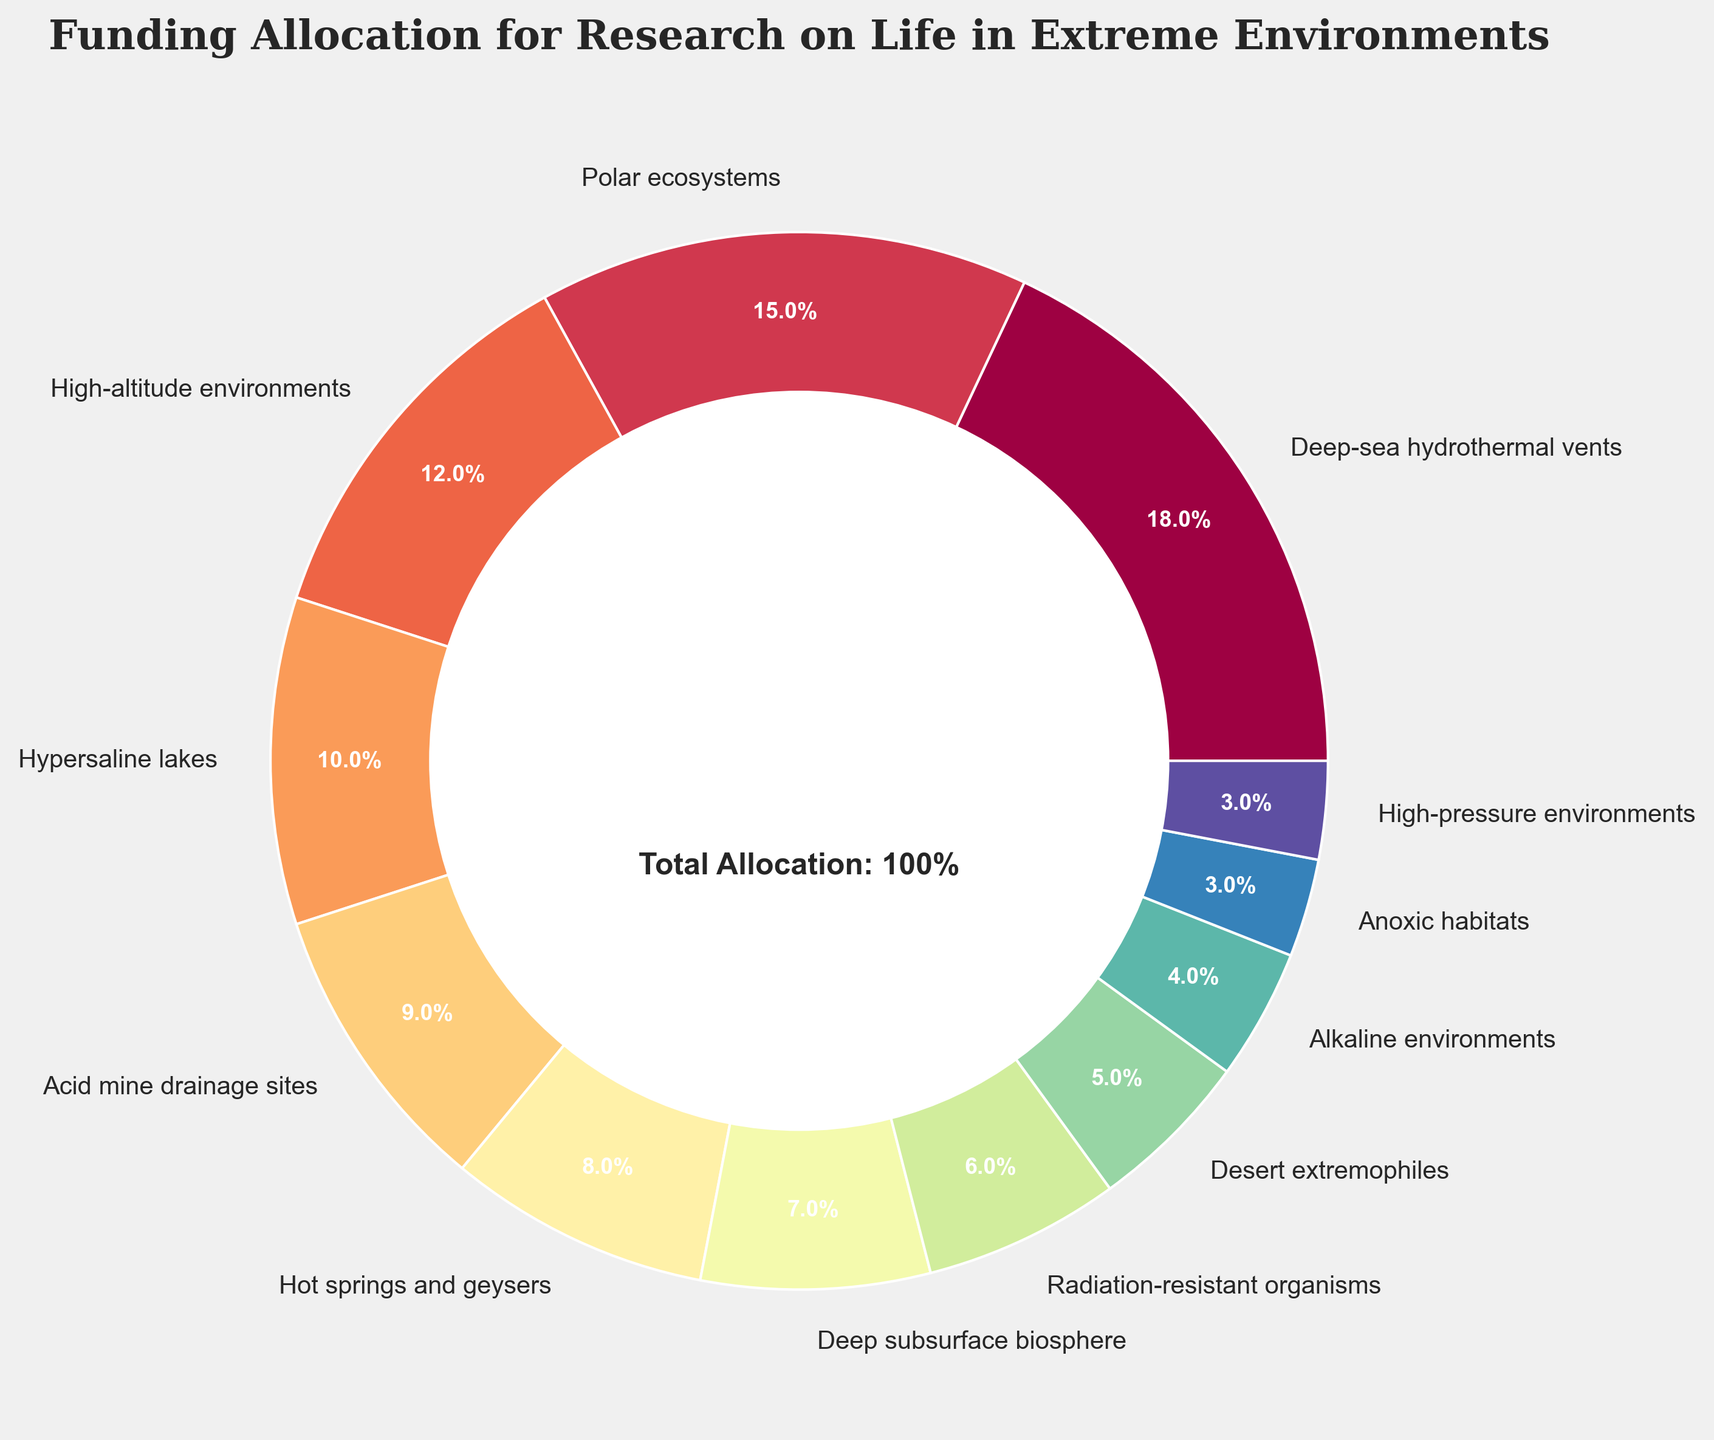What percentage of the total funding is allocated to the two lowest-funded research areas combined? First, identify the two lowest-funded research areas: Anoxic habitats (3%) and High-pressure environments (3%). Then, add their funding allocations: 3% + 3% = 6%.
Answer: 6% Which research area receives the highest funding allocation? Look at the slice of the pie chart that represents the highest percentage. In this case, it is the Deep-sea hydrothermal vents at 18%.
Answer: Deep-sea hydrothermal vents How much more funding is allocated to Polar ecosystems compared to Desert extremophiles? First, identify the funding allocations: Polar ecosystems (15%) and Desert extremophiles (5%). Then, subtract the smaller from the larger: 15% - 5% = 10%.
Answer: 10% What is the combined funding allocation for research in high-altitude environments and radiation-resistant organisms? Locate the slices representing High-altitude environments (12%) and Radiation-resistant organisms (6%), then add their percentages: 12% + 6% = 18%.
Answer: 18% Which research area receives 10% of the funding allocation? Identify the slice of the pie chart labeled with 10%. This area corresponds to Hypersaline lakes.
Answer: Hypersaline lakes Do Alkaline environments receive more or less funding than Acid mine drainage sites? Compare the funding allocations: Alkaline environments (4%) and Acid mine drainage sites (9%). Alkaline environments receive less funding.
Answer: Less List the research areas that receive less than 10% of the total funding. Identify slices that represent less than 10%: Hot springs and geysers (8%), Deep subsurface biosphere (7%), Radiation-resistant organisms (6%), Desert extremophiles (5%), Alkaline environments (4%), Anoxic habitats (3%), High-pressure environments (3%).
Answer: Hot springs and geysers, Deep subsurface biosphere, Radiation-resistant organisms, Desert extremophiles, Alkaline environments, Anoxic habitats, High-pressure environments What is the difference in funding allocation between the highest-funded and lowest-funded research areas? Compare the highest-funded area (Deep-sea hydrothermal vents at 18%) and the lowest-funded areas (Anoxic habitats and High-pressure environments, both at 3%). Subtract the smaller from the larger: 18% - 3% = 15%.
Answer: 15% What fraction of the total funding is allocated to Deep-sea hydrothermal vents and Alkaline environments? Identify the funding allocations: Deep-sea hydrothermal vents (18%) and Alkaline environments (4%). Add these percentages: 18% + 4% = 22%, which in fraction form is 22/100 or 11/50.
Answer: 11/50 Which research area is directly opposite High-altitude environments in terms of funding allocation on the pie chart? Identify slices of the pie chart: High-altitude environments (12%) is directly opposite a slice with the same surface area percentage, which in this case is not directly opposite but Desert extremophiles (5%) is closest visually.
Answer: Desert extremophiles 